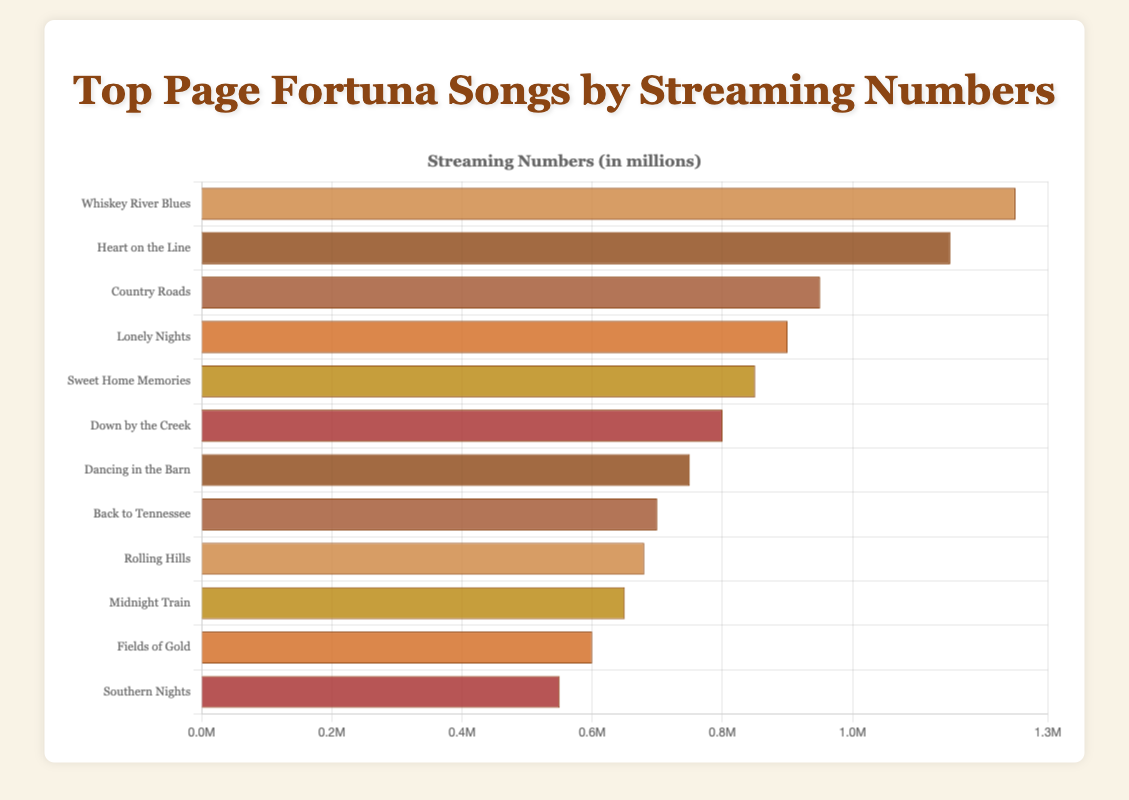Which song has the highest streaming numbers? "Whiskey River Blues" has the highest streaming numbers as indicated by the longest bar on the chart.
Answer: Whiskey River Blues Which song has the second-highest number of streams? The song with the second-longest bar after "Whiskey River Blues" is "Heart on the Line."
Answer: Heart on the Line How many streams do "Lonely Nights" and "Down by the Creek" have combined? "Lonely Nights" has 900,000 streams, and "Down by the Creek" has 800,000 streams. Adding these gives us a total of 1,700,000 streams.
Answer: 1,700,000 Rank the top three songs by streaming numbers. The top three songs by streaming numbers are visually identified by the bar length: "Whiskey River Blues," "Heart on the Line," and "Country Roads."
Answer: Whiskey River Blues, Heart on the Line, Country Roads How much more popular is "Whiskey River Blues" compared to "Country Roads"? "Whiskey River Blues" has 1,250,000 streams and "Country Roads" has 950,000 streams. The difference is 1,250,000 - 950,000 = 300,000 streams.
Answer: 300,000 Is "Back to Tennessee" more popular than "Rolling Hills"? The bar for "Back to Tennessee" (700,000 streams) is longer than that for "Rolling Hills" (680,000 streams), indicating it is more popular.
Answer: Yes What is the average number of streams for all the listed songs? Sum each song's streams: 1,250,000 + 1,150,000 + 950,000 + 900,000 + 850,000 + 800,000 + 750,000 + 700,000 + 680,000 + 650,000 + 600,000 + 550,000 = 10,830,000. Divide by the number of songs, which is 12. The average is 10,830,000 / 12 ≈ 902,500 streams.
Answer: 902,500 Which song has fewer streams: "Southern Nights" or "Midnight Train"? The bar for "Southern Nights" (550,000 streams) is shorter than the bar for "Midnight Train" (650,000 streams), indicating fewer streams.
Answer: Southern Nights What is the median value of the streaming numbers? First, list all the numbers in ascending order: 550,000, 600,000, 650,000, 680,000, 700,000, 750,000, 800,000, 850,000, 900,000, 950,000, 1,150,000, 1,250,000. Since there are 12 values, the median is the average of the 6th and 7th values: (750,000 + 800,000) / 2 = 775,000
Answer: 775,000 How many more streams does "Sweet Home Memories" have compared to "Southern Nights"? "Sweet Home Memories" has 850,000 streams and "Southern Nights" has 550,000 streams. The difference is 850,000 - 550,000 = 300,000 streams.
Answer: 300,000 